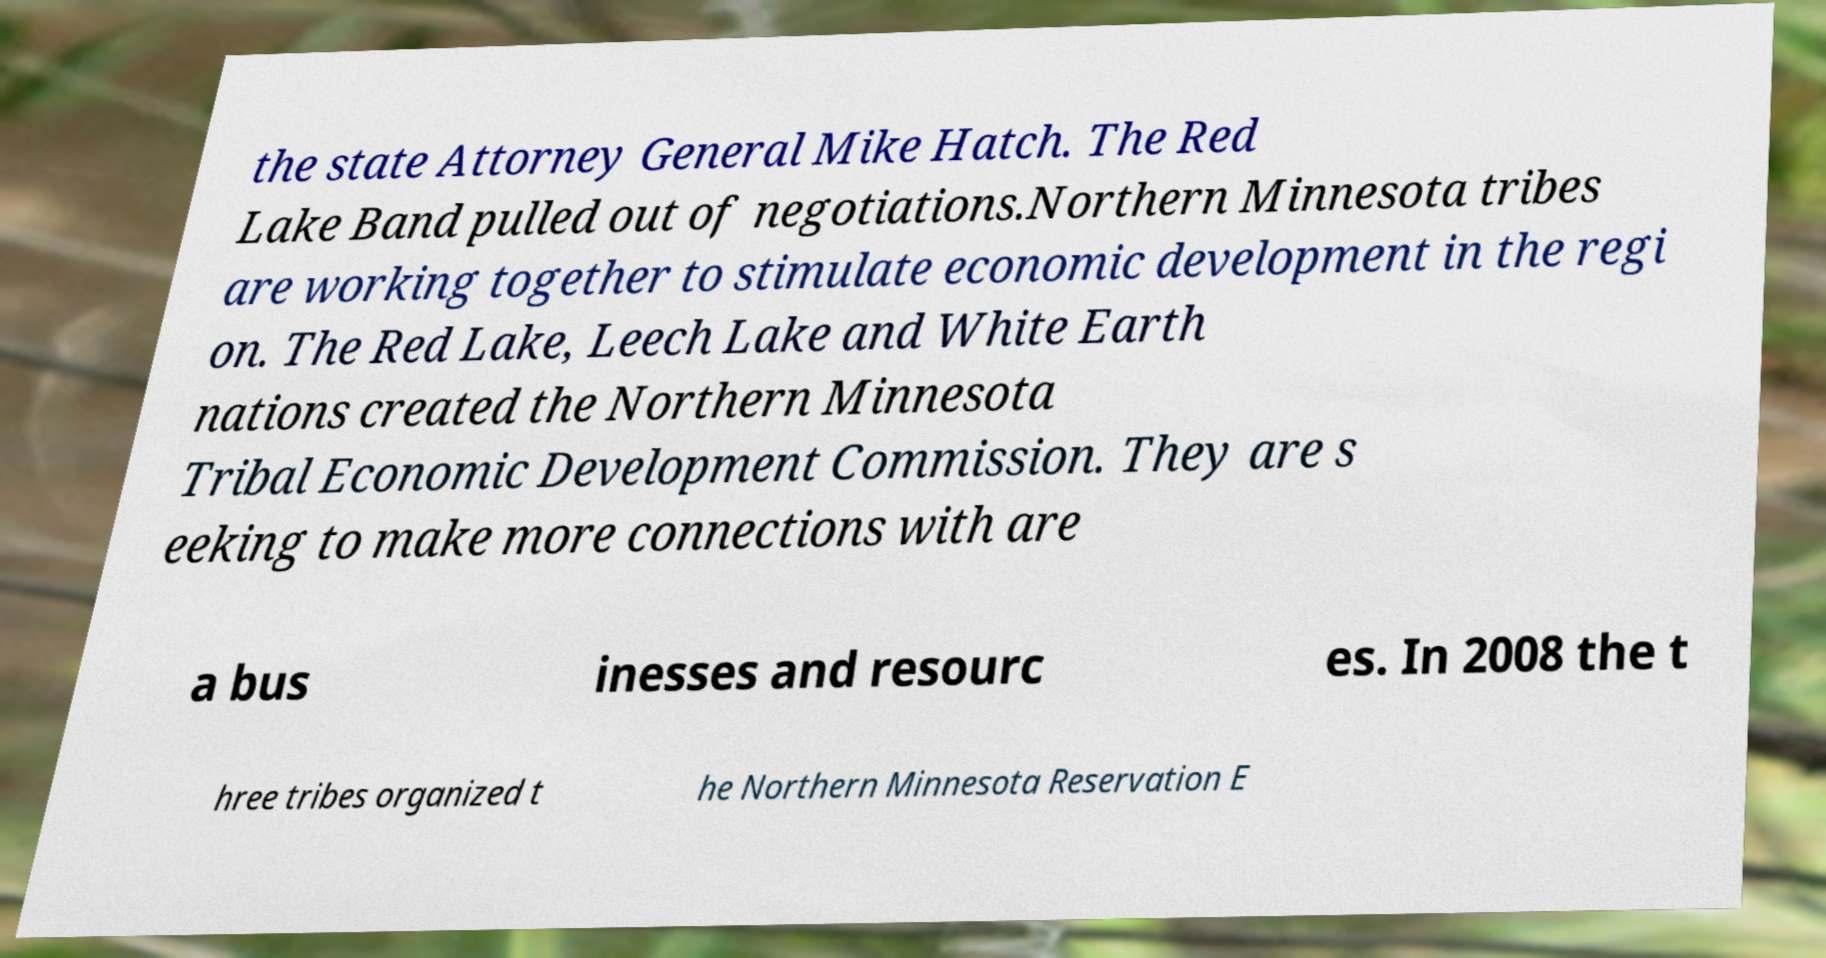For documentation purposes, I need the text within this image transcribed. Could you provide that? the state Attorney General Mike Hatch. The Red Lake Band pulled out of negotiations.Northern Minnesota tribes are working together to stimulate economic development in the regi on. The Red Lake, Leech Lake and White Earth nations created the Northern Minnesota Tribal Economic Development Commission. They are s eeking to make more connections with are a bus inesses and resourc es. In 2008 the t hree tribes organized t he Northern Minnesota Reservation E 